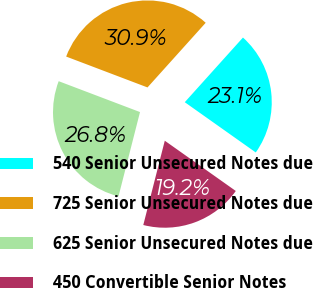Convert chart to OTSL. <chart><loc_0><loc_0><loc_500><loc_500><pie_chart><fcel>540 Senior Unsecured Notes due<fcel>725 Senior Unsecured Notes due<fcel>625 Senior Unsecured Notes due<fcel>450 Convertible Senior Notes<nl><fcel>23.14%<fcel>30.89%<fcel>26.8%<fcel>19.17%<nl></chart> 